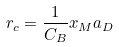<formula> <loc_0><loc_0><loc_500><loc_500>r _ { c } = \frac { 1 } { C _ { B } } x _ { M } a _ { D }</formula> 